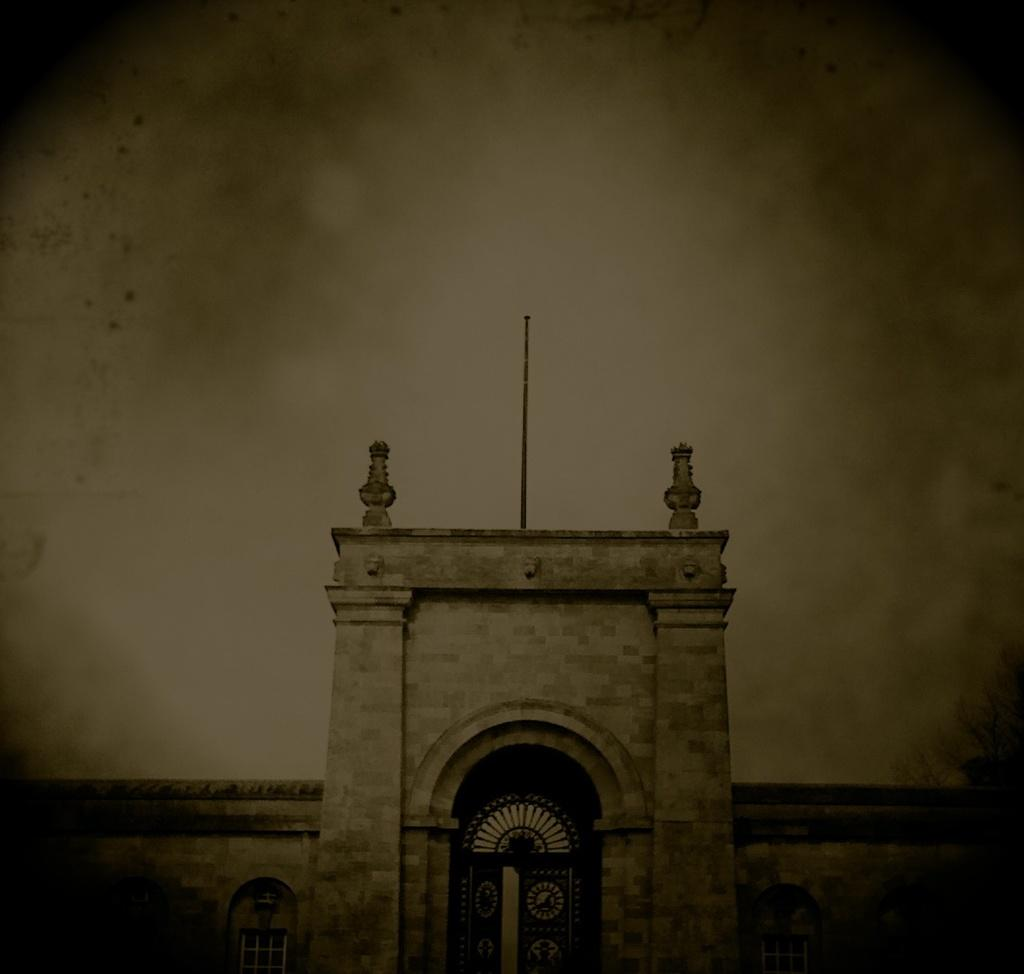What is the main subject of the image? There is a building in the center of the image. Can you describe the background of the image? The background of the image is blurred. How many knots are tied in the linen in the image? There is no linen or knots present in the image. What type of power source is visible in the image? There is no power source visible in the image; it only features a building and a blurred background. 